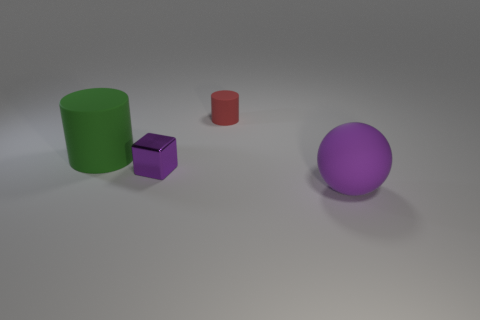Add 4 large green rubber spheres. How many objects exist? 8 Subtract all blocks. How many objects are left? 3 Subtract all big brown matte cylinders. Subtract all big things. How many objects are left? 2 Add 4 tiny red matte cylinders. How many tiny red matte cylinders are left? 5 Add 1 big green matte things. How many big green matte things exist? 2 Subtract 0 blue cubes. How many objects are left? 4 